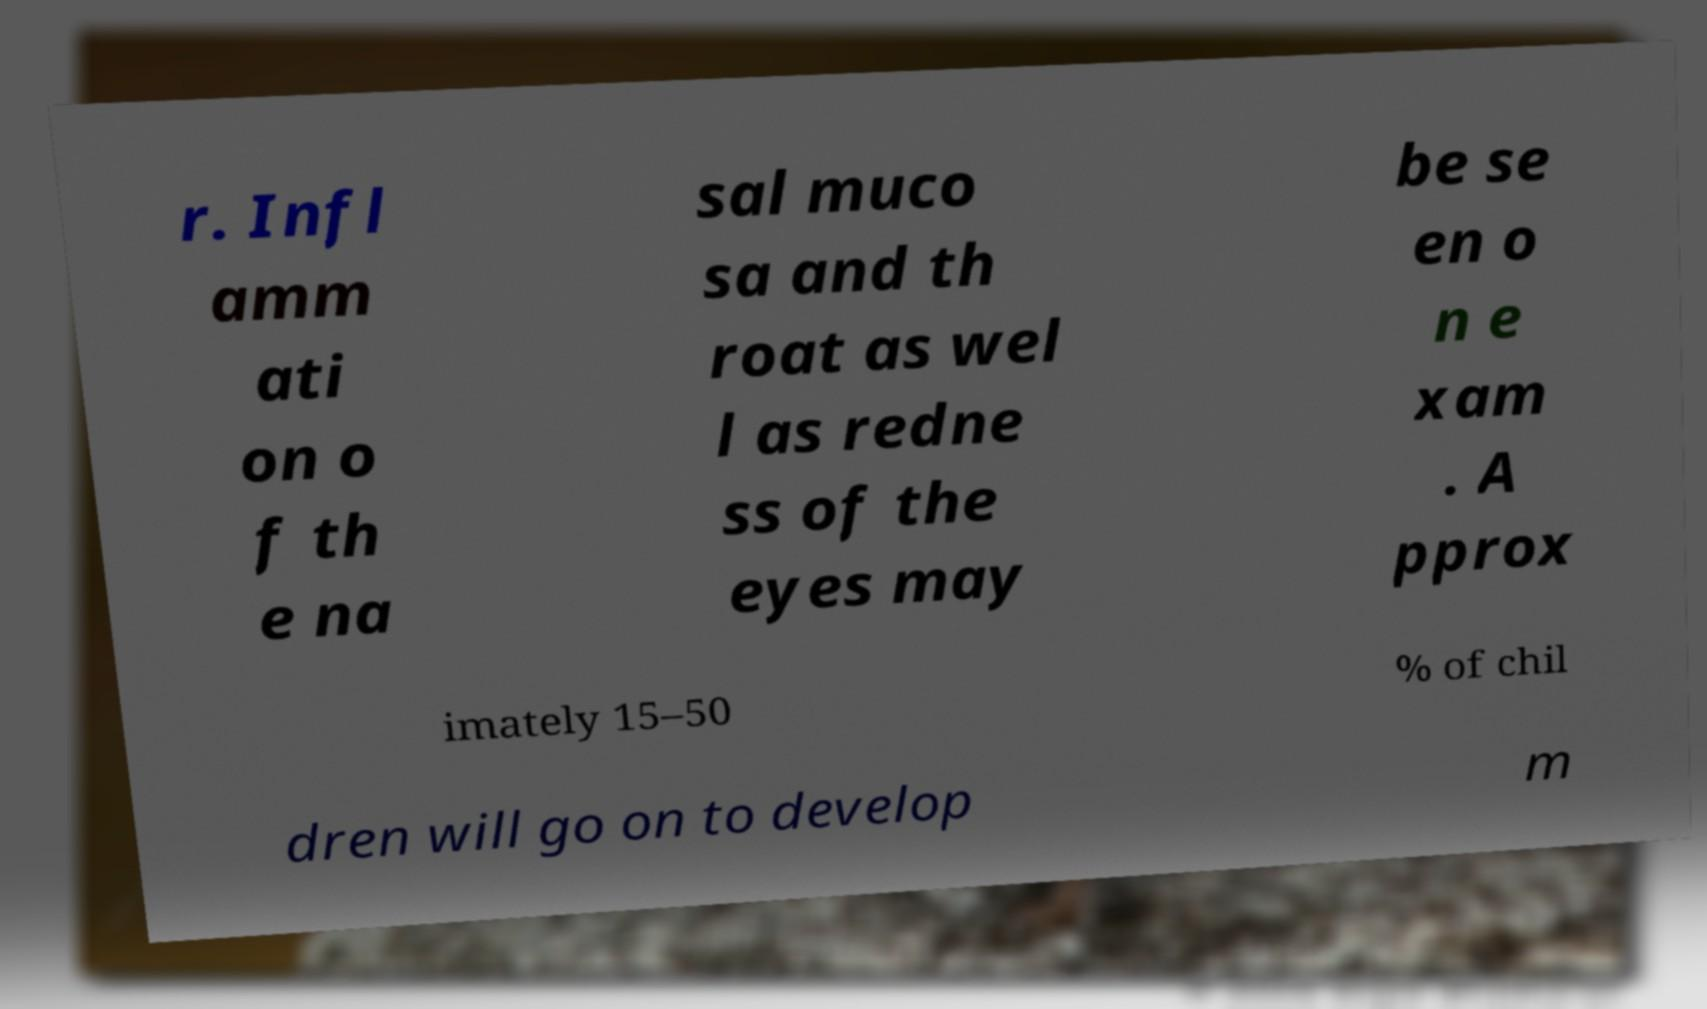Can you accurately transcribe the text from the provided image for me? r. Infl amm ati on o f th e na sal muco sa and th roat as wel l as redne ss of the eyes may be se en o n e xam . A pprox imately 15–50 % of chil dren will go on to develop m 